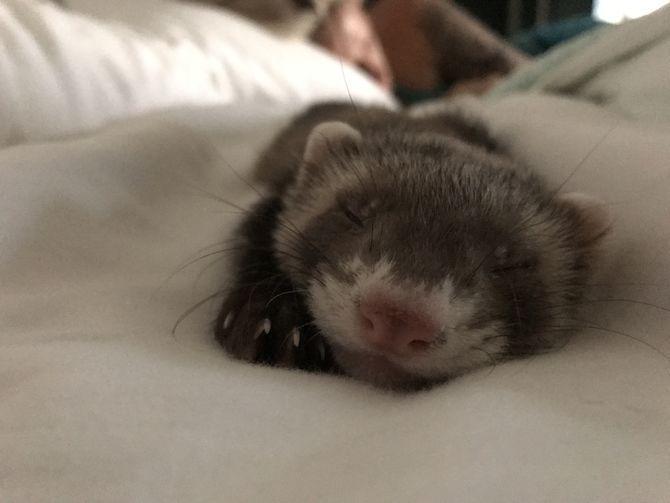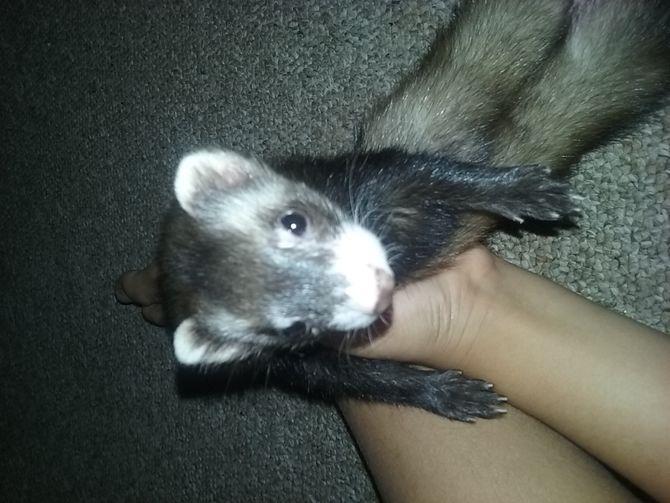The first image is the image on the left, the second image is the image on the right. Given the left and right images, does the statement "Two ferrets have their mouths open." hold true? Answer yes or no. No. The first image is the image on the left, the second image is the image on the right. Examine the images to the left and right. Is the description "A ferret with extended tongue is visible." accurate? Answer yes or no. No. 